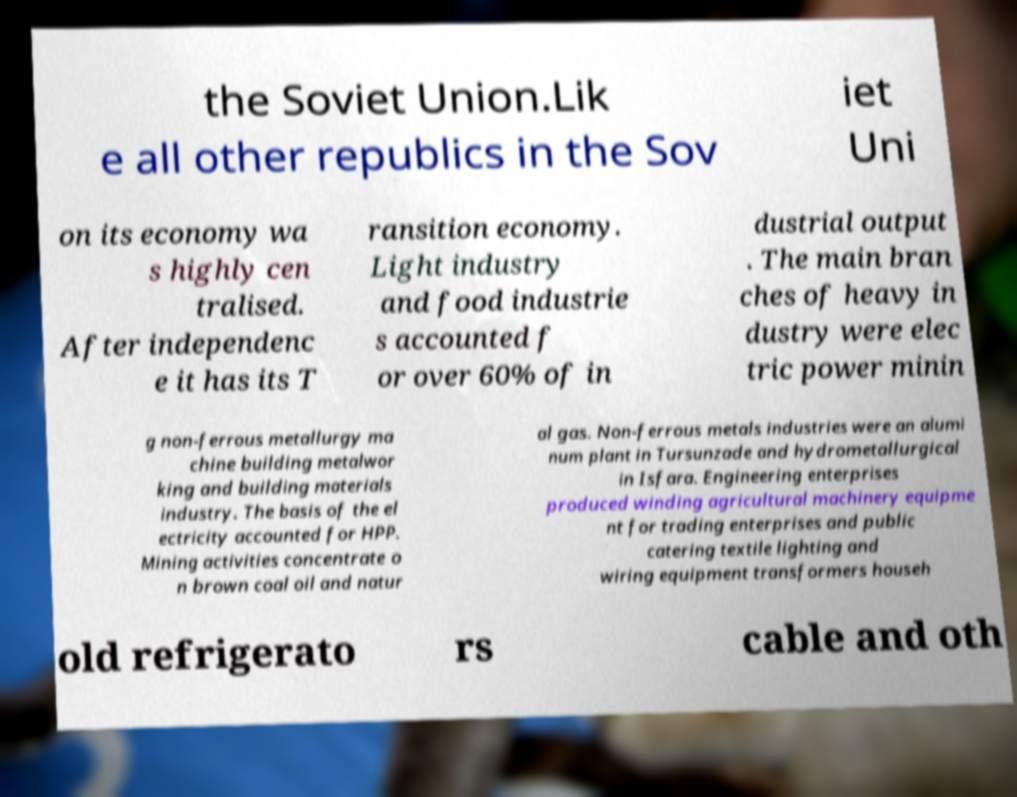Could you extract and type out the text from this image? the Soviet Union.Lik e all other republics in the Sov iet Uni on its economy wa s highly cen tralised. After independenc e it has its T ransition economy. Light industry and food industrie s accounted f or over 60% of in dustrial output . The main bran ches of heavy in dustry were elec tric power minin g non-ferrous metallurgy ma chine building metalwor king and building materials industry. The basis of the el ectricity accounted for HPP. Mining activities concentrate o n brown coal oil and natur al gas. Non-ferrous metals industries were an alumi num plant in Tursunzade and hydrometallurgical in Isfara. Engineering enterprises produced winding agricultural machinery equipme nt for trading enterprises and public catering textile lighting and wiring equipment transformers househ old refrigerato rs cable and oth 